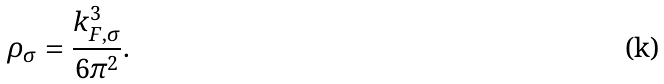Convert formula to latex. <formula><loc_0><loc_0><loc_500><loc_500>\rho _ { \sigma } = \frac { k ^ { 3 } _ { F , \sigma } } { 6 \pi ^ { 2 } } .</formula> 